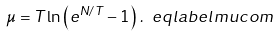<formula> <loc_0><loc_0><loc_500><loc_500>\mu = T \ln \left ( e ^ { N / T } - 1 \right ) \, . \ e q l a b e l { m u c o m }</formula> 